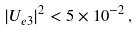<formula> <loc_0><loc_0><loc_500><loc_500>| U _ { e 3 } | ^ { 2 } < 5 \times 1 0 ^ { - 2 } \, ,</formula> 